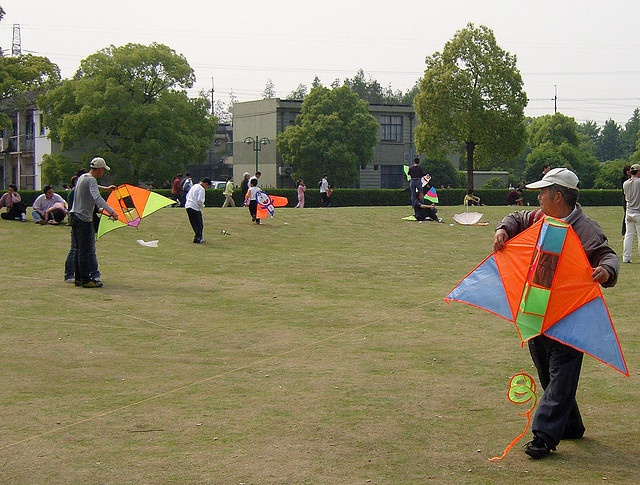Describe the objects in this image and their specific colors. I can see kite in white, red, and gray tones, people in white, black, gray, maroon, and darkgray tones, people in white, black, gray, olive, and darkgreen tones, people in white, black, gray, darkgray, and maroon tones, and kite in white, salmon, khaki, orange, and olive tones in this image. 